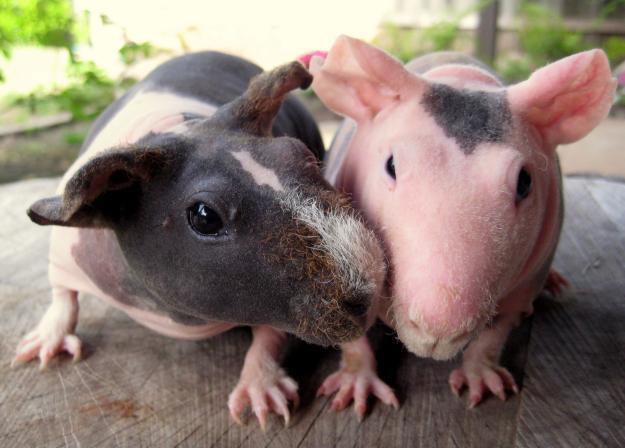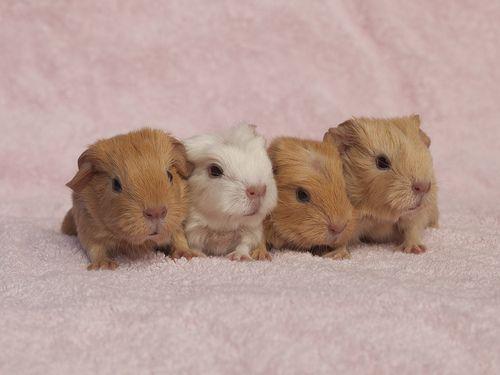The first image is the image on the left, the second image is the image on the right. Given the left and right images, does the statement "In one image, three gerbils are being held in one or more human hands that have the palm up and fingers extended." hold true? Answer yes or no. No. The first image is the image on the left, the second image is the image on the right. Assess this claim about the two images: "Three hamsters are held in human hands in one image.". Correct or not? Answer yes or no. No. 